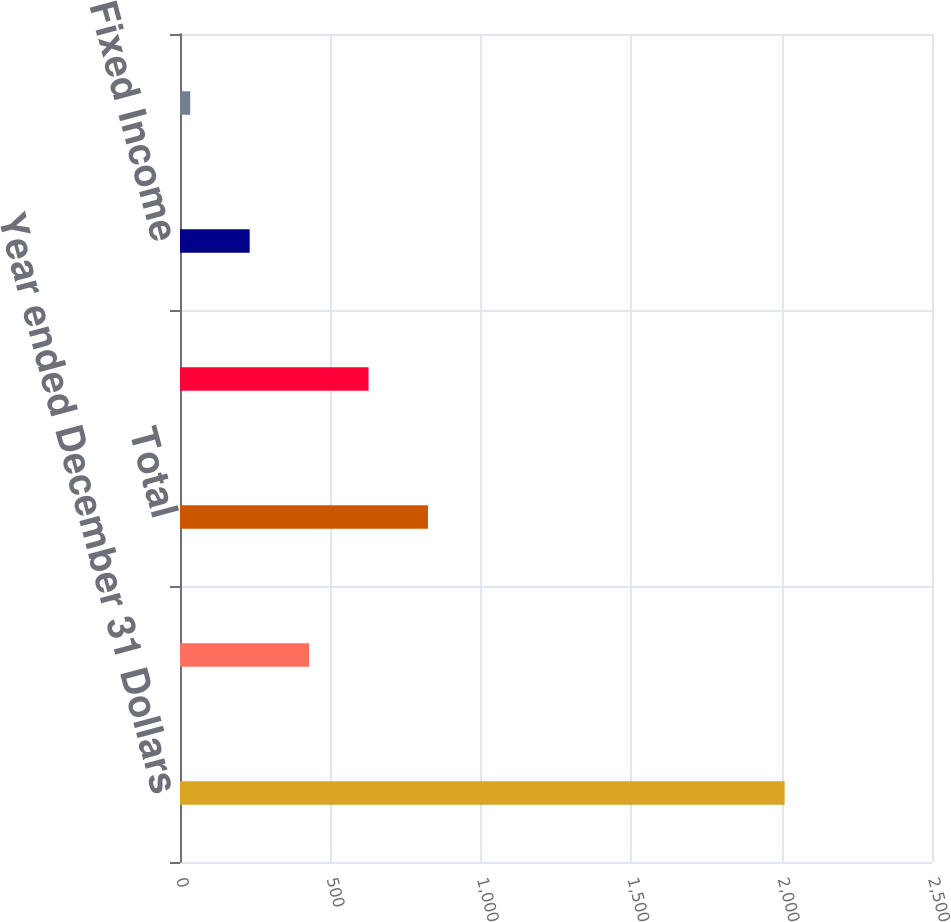Convert chart. <chart><loc_0><loc_0><loc_500><loc_500><bar_chart><fcel>Year ended December 31 Dollars<fcel>Institutional<fcel>Total<fcel>Equity<fcel>Fixed Income<fcel>Liquidity/Other<nl><fcel>2010<fcel>429.2<fcel>824.4<fcel>626.8<fcel>231.6<fcel>34<nl></chart> 